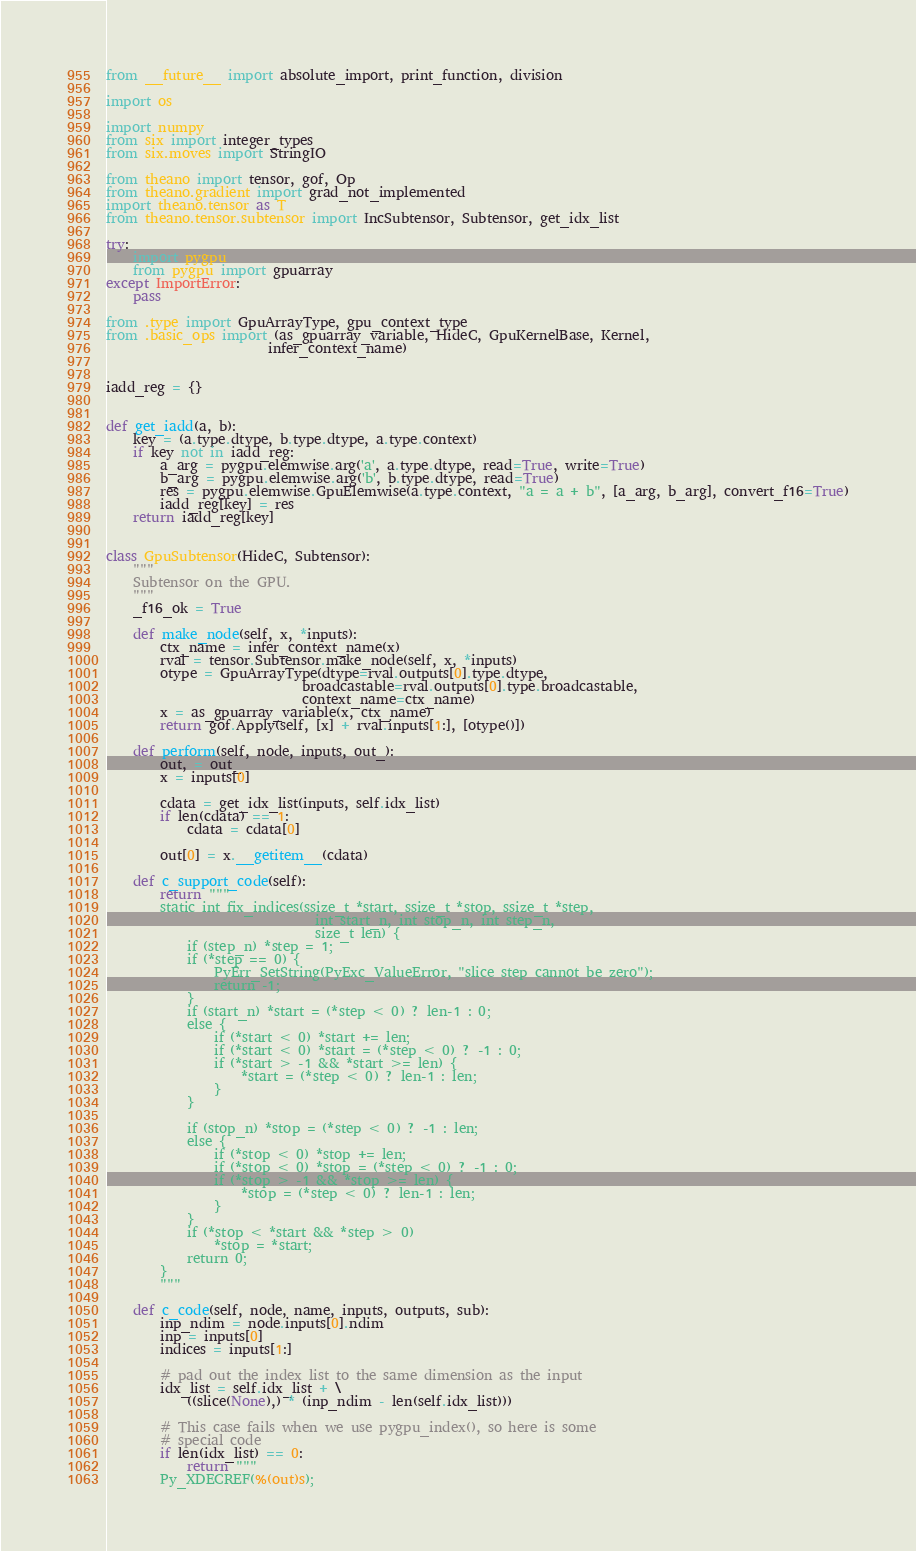<code> <loc_0><loc_0><loc_500><loc_500><_Python_>from __future__ import absolute_import, print_function, division

import os

import numpy
from six import integer_types
from six.moves import StringIO

from theano import tensor, gof, Op
from theano.gradient import grad_not_implemented
import theano.tensor as T
from theano.tensor.subtensor import IncSubtensor, Subtensor, get_idx_list

try:
    import pygpu
    from pygpu import gpuarray
except ImportError:
    pass

from .type import GpuArrayType, gpu_context_type
from .basic_ops import (as_gpuarray_variable, HideC, GpuKernelBase, Kernel,
                        infer_context_name)


iadd_reg = {}


def get_iadd(a, b):
    key = (a.type.dtype, b.type.dtype, a.type.context)
    if key not in iadd_reg:
        a_arg = pygpu.elemwise.arg('a', a.type.dtype, read=True, write=True)
        b_arg = pygpu.elemwise.arg('b', b.type.dtype, read=True)
        res = pygpu.elemwise.GpuElemwise(a.type.context, "a = a + b", [a_arg, b_arg], convert_f16=True)
        iadd_reg[key] = res
    return iadd_reg[key]


class GpuSubtensor(HideC, Subtensor):
    """
    Subtensor on the GPU.
    """
    _f16_ok = True

    def make_node(self, x, *inputs):
        ctx_name = infer_context_name(x)
        rval = tensor.Subtensor.make_node(self, x, *inputs)
        otype = GpuArrayType(dtype=rval.outputs[0].type.dtype,
                             broadcastable=rval.outputs[0].type.broadcastable,
                             context_name=ctx_name)
        x = as_gpuarray_variable(x, ctx_name)
        return gof.Apply(self, [x] + rval.inputs[1:], [otype()])

    def perform(self, node, inputs, out_):
        out, = out_
        x = inputs[0]

        cdata = get_idx_list(inputs, self.idx_list)
        if len(cdata) == 1:
            cdata = cdata[0]

        out[0] = x.__getitem__(cdata)

    def c_support_code(self):
        return """
        static int fix_indices(ssize_t *start, ssize_t *stop, ssize_t *step,
                               int start_n, int stop_n, int step_n,
                               size_t len) {
            if (step_n) *step = 1;
            if (*step == 0) {
                PyErr_SetString(PyExc_ValueError, "slice step cannot be zero");
                return -1;
            }
            if (start_n) *start = (*step < 0) ? len-1 : 0;
            else {
                if (*start < 0) *start += len;
                if (*start < 0) *start = (*step < 0) ? -1 : 0;
                if (*start > -1 && *start >= len) {
                    *start = (*step < 0) ? len-1 : len;
                }
            }

            if (stop_n) *stop = (*step < 0) ? -1 : len;
            else {
                if (*stop < 0) *stop += len;
                if (*stop < 0) *stop = (*step < 0) ? -1 : 0;
                if (*stop > -1 && *stop >= len) {
                    *stop = (*step < 0) ? len-1 : len;
                }
            }
            if (*stop < *start && *step > 0)
                *stop = *start;
            return 0;
        }
        """

    def c_code(self, node, name, inputs, outputs, sub):
        inp_ndim = node.inputs[0].ndim
        inp = inputs[0]
        indices = inputs[1:]

        # pad out the index list to the same dimension as the input
        idx_list = self.idx_list + \
            ((slice(None),) * (inp_ndim - len(self.idx_list)))

        # This case fails when we use pygpu_index(), so here is some
        # special code
        if len(idx_list) == 0:
            return """
        Py_XDECREF(%(out)s);</code> 